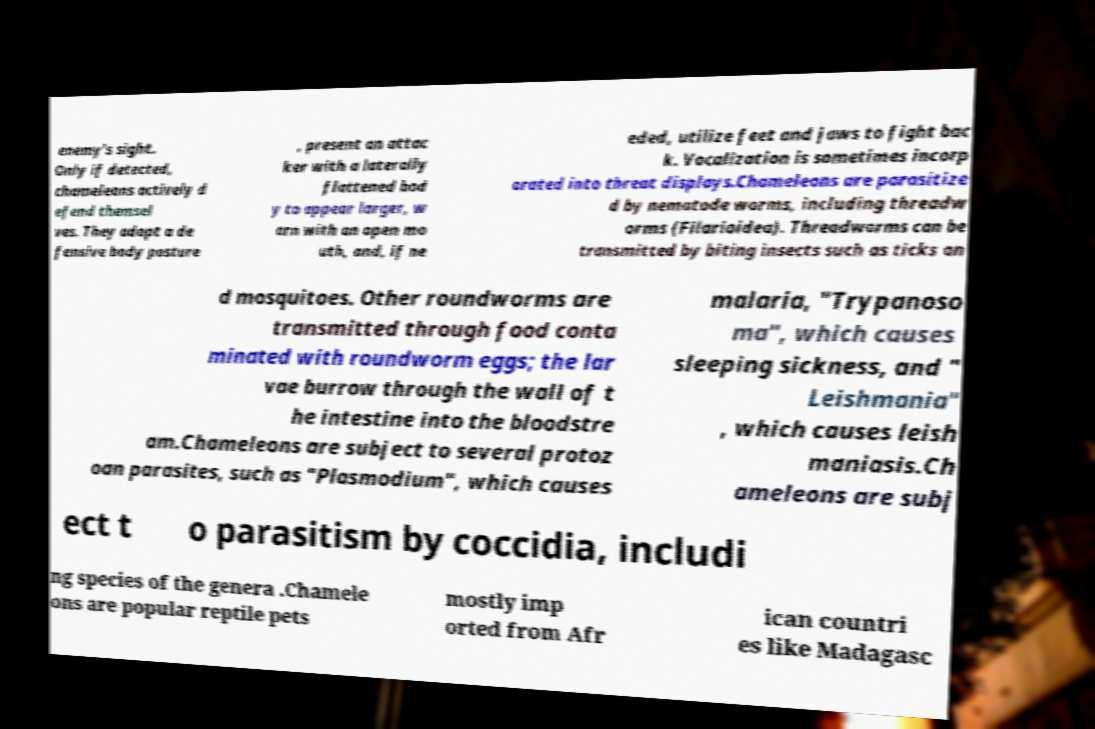Could you assist in decoding the text presented in this image and type it out clearly? enemy's sight. Only if detected, chameleons actively d efend themsel ves. They adopt a de fensive body posture , present an attac ker with a laterally flattened bod y to appear larger, w arn with an open mo uth, and, if ne eded, utilize feet and jaws to fight bac k. Vocalization is sometimes incorp orated into threat displays.Chameleons are parasitize d by nematode worms, including threadw orms (Filarioidea). Threadworms can be transmitted by biting insects such as ticks an d mosquitoes. Other roundworms are transmitted through food conta minated with roundworm eggs; the lar vae burrow through the wall of t he intestine into the bloodstre am.Chameleons are subject to several protoz oan parasites, such as "Plasmodium", which causes malaria, "Trypanoso ma", which causes sleeping sickness, and " Leishmania" , which causes leish maniasis.Ch ameleons are subj ect t o parasitism by coccidia, includi ng species of the genera .Chamele ons are popular reptile pets mostly imp orted from Afr ican countri es like Madagasc 